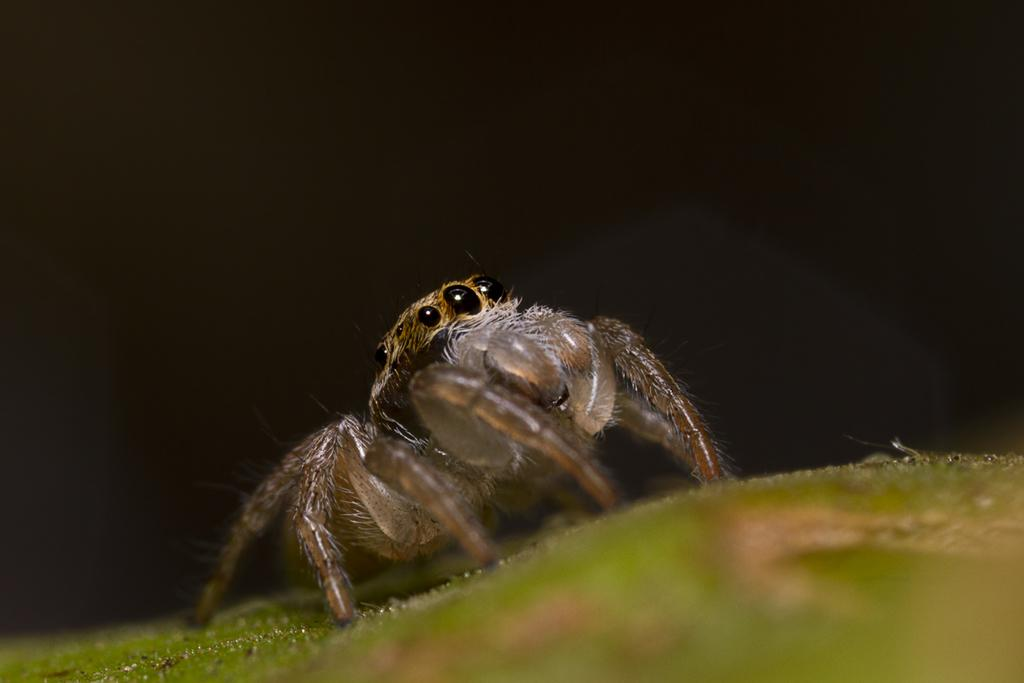What type of creature can be seen in the image? There is an insect in the image. Where is the insect located? The insect is on the grass. How many tomatoes are visible in the image? There are no tomatoes present in the image. What type of tail can be seen on the insect in the image? Insects do not have tails, and there is no tail visible in the image. 